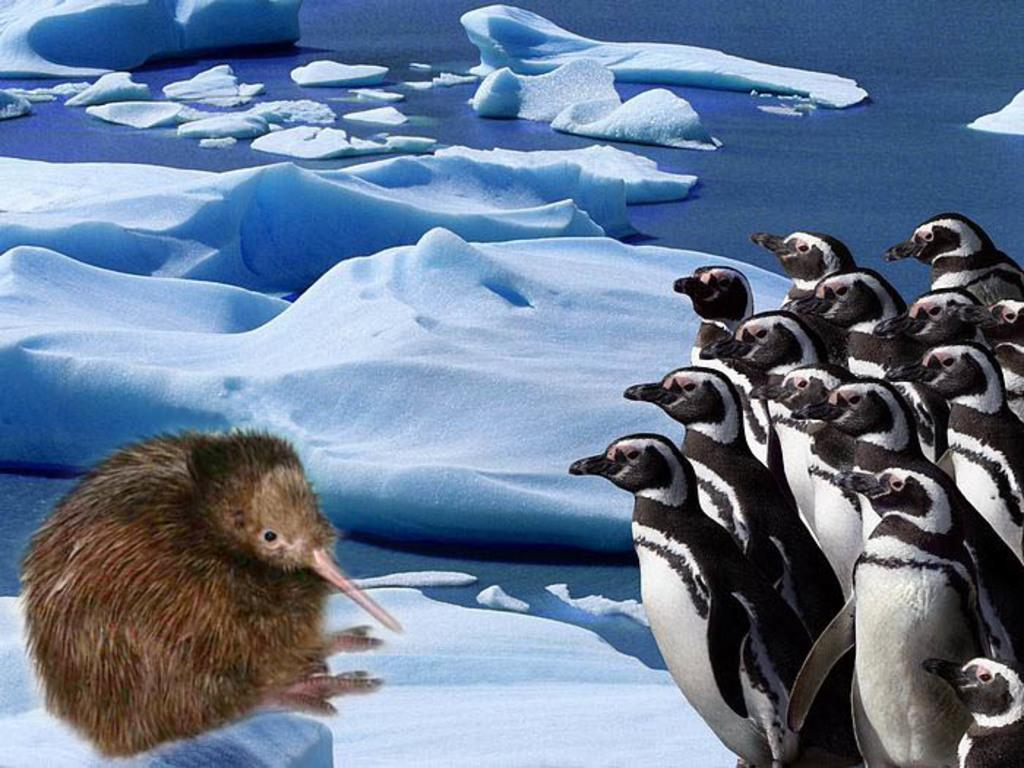What type of animals are in the image? There are penguins in the image. Can you describe the animal in the image? There is an animal in the image, which is a penguin. What can be seen in the background of the image? There is water and snow visible in the background of the image. What type of doctor is present in the image? There is no doctor present in the image; it features penguins in a snowy and watery environment. What can be seen on the calendar in the image? There is no calendar present in the image. 